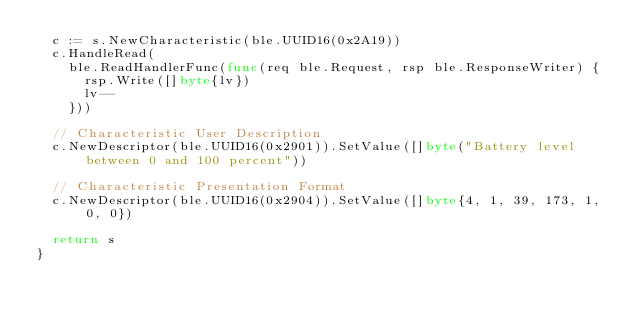Convert code to text. <code><loc_0><loc_0><loc_500><loc_500><_Go_>	c := s.NewCharacteristic(ble.UUID16(0x2A19))
	c.HandleRead(
		ble.ReadHandlerFunc(func(req ble.Request, rsp ble.ResponseWriter) {
			rsp.Write([]byte{lv})
			lv--
		}))

	// Characteristic User Description
	c.NewDescriptor(ble.UUID16(0x2901)).SetValue([]byte("Battery level between 0 and 100 percent"))

	// Characteristic Presentation Format
	c.NewDescriptor(ble.UUID16(0x2904)).SetValue([]byte{4, 1, 39, 173, 1, 0, 0})

	return s
}
</code> 